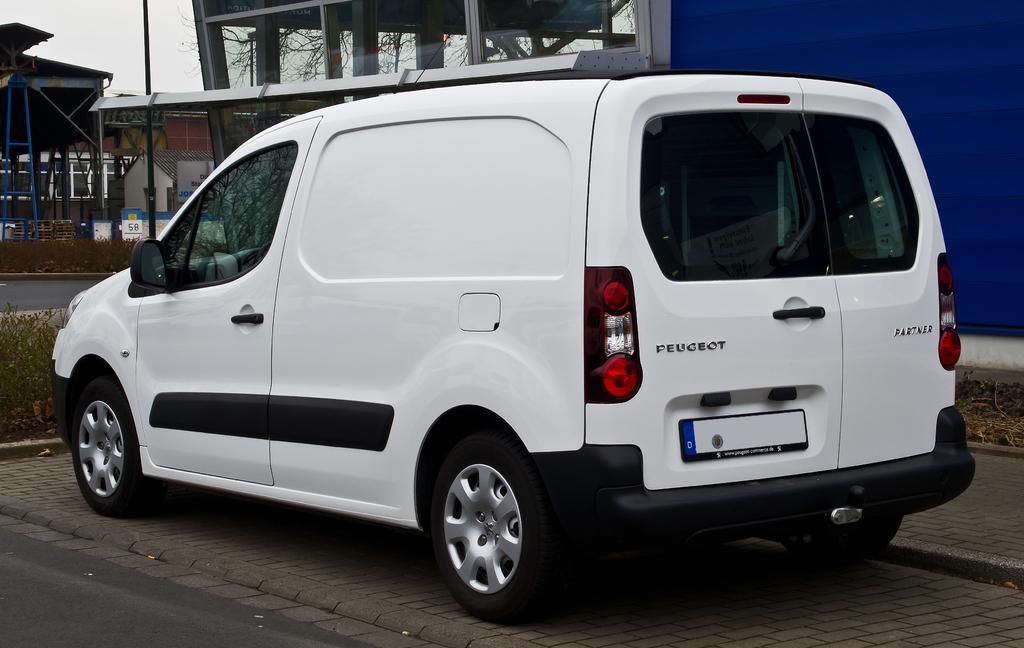How would you summarize this image in a sentence or two? In this image we can see a car, roadside, plants, poles, branches, boards, and buildings. In the background there is sky. 